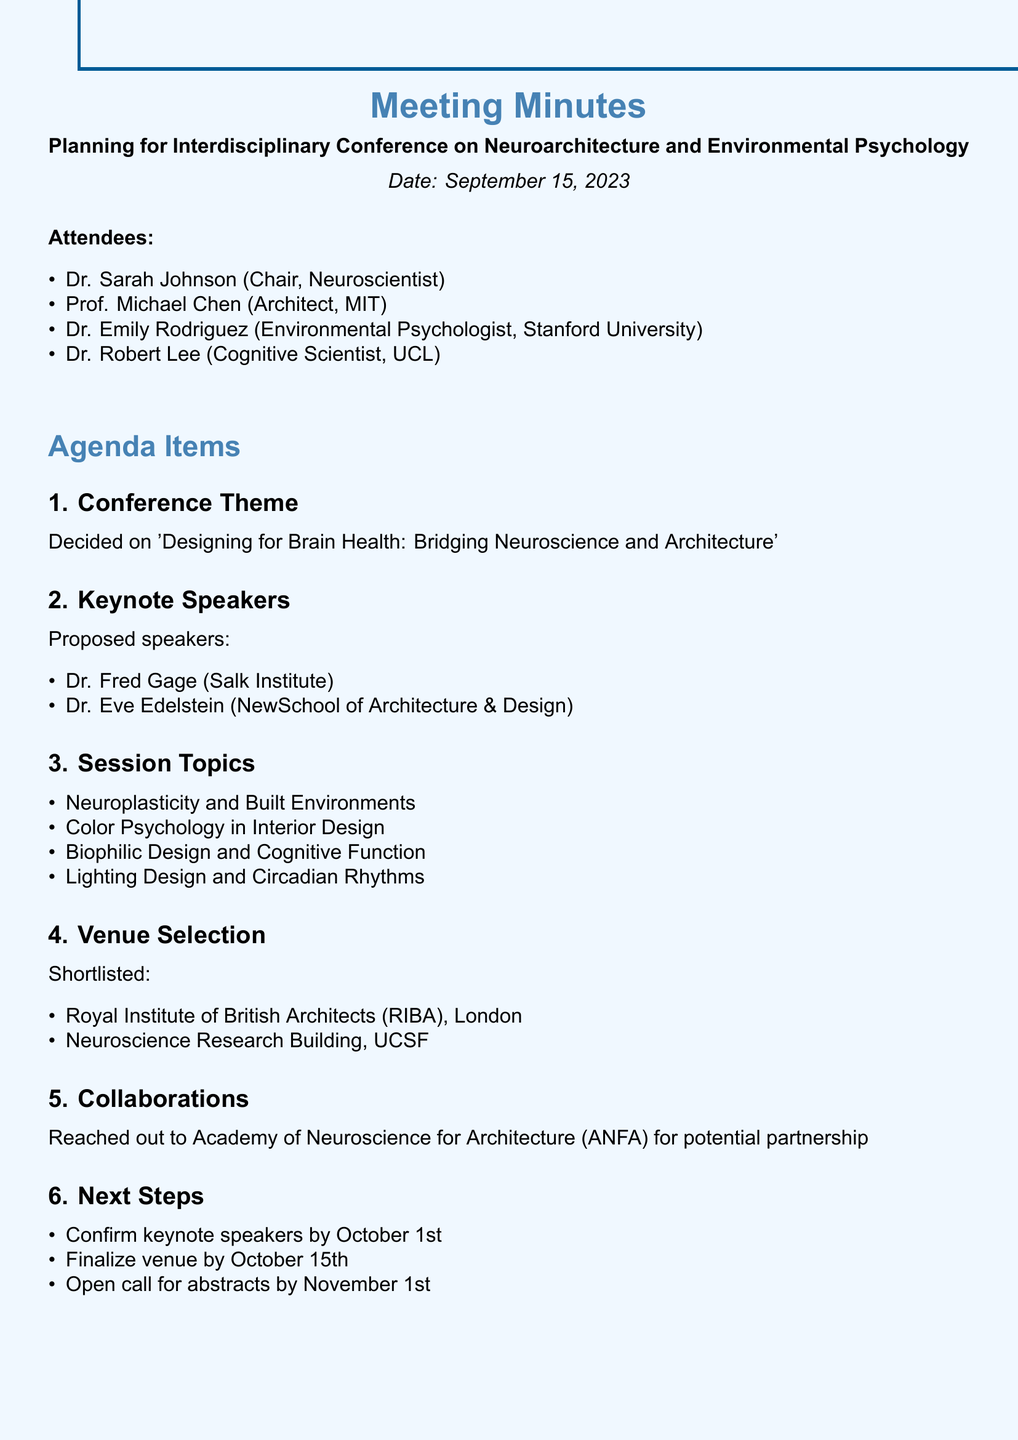What is the date of the meeting? The date of the meeting is mentioned at the beginning of the document.
Answer: September 15, 2023 Who is the chair of the meeting? The chair of the meeting is listed among the attendees.
Answer: Dr. Sarah Johnson What is the conference theme? The conference theme is specified in the agenda items section.
Answer: Designing for Brain Health: Bridging Neuroscience and Architecture Which venue was shortlisted in London? One of the shortlisted venues is mentioned in the venue selection section.
Answer: Royal Institute of British Architects (RIBA) How many session topics were proposed? The number of session topics can be counted from the list provided in the agenda.
Answer: Four By when do we need to confirm keynote speakers? The deadline for confirming keynote speakers is outlined in the next steps section.
Answer: October 1st Who are the proposed keynote speakers? The proposed keynote speakers are listed in the respective agenda item.
Answer: Dr. Fred Gage, Dr. Eve Edelstein What collaboration has been initiated? The document mentions a specific organization reached out for potential collaboration.
Answer: Academy of Neuroscience for Architecture (ANFA) 